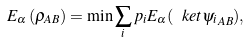Convert formula to latex. <formula><loc_0><loc_0><loc_500><loc_500>E _ { \alpha } \left ( \rho _ { A B } \right ) = \min \sum _ { i } p _ { i } E _ { \alpha } ( \ k e t { \psi _ { i } } _ { A B } ) ,</formula> 